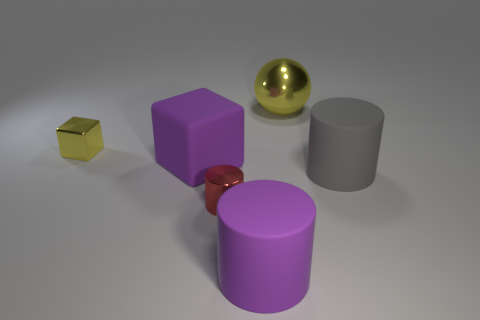How many yellow metal things are there?
Your answer should be very brief. 2. There is a big thing behind the large purple object behind the matte cylinder that is to the left of the big yellow metallic thing; what is it made of?
Ensure brevity in your answer.  Metal. Are there any large gray objects made of the same material as the big gray cylinder?
Provide a succinct answer. No. Is the material of the purple cube the same as the sphere?
Your answer should be very brief. No. How many spheres are big yellow shiny things or small red shiny things?
Your answer should be compact. 1. There is a big thing that is the same material as the tiny yellow object; what is its color?
Your response must be concise. Yellow. Are there fewer small cubes than purple things?
Your answer should be compact. Yes. Does the big purple matte object left of the small red metallic object have the same shape as the large purple object that is in front of the big gray matte thing?
Your response must be concise. No. What number of objects are either big gray blocks or big purple cylinders?
Your response must be concise. 1. There is another cylinder that is the same size as the purple cylinder; what is its color?
Your response must be concise. Gray. 